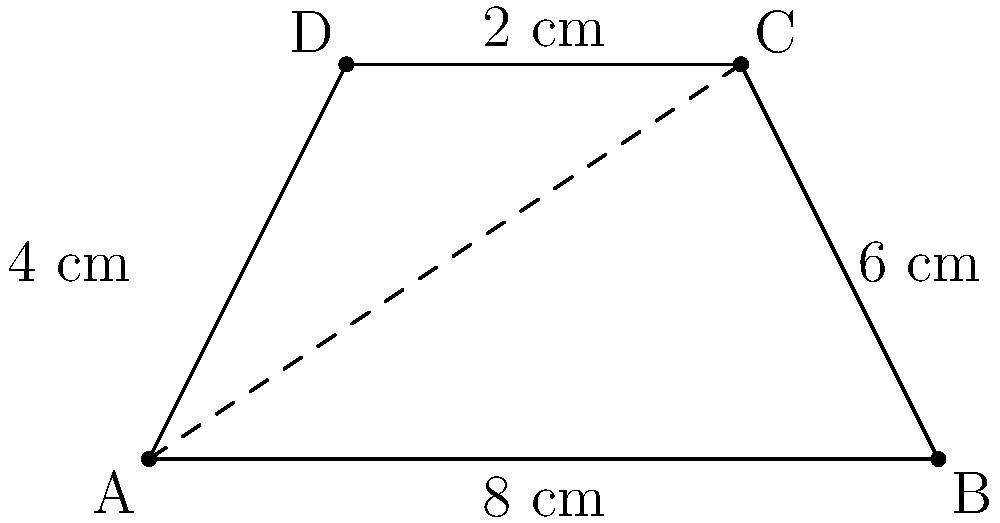In a data flow diagram represented as a trapezoid, the parallel sides measure 2 cm and 8 cm, while the height is 4 cm. Calculate the area of this trapezoid-shaped data flow diagram in square centimeters. To calculate the area of a trapezoid, we use the formula:

$$A = \frac{1}{2}(b_1 + b_2)h$$

Where:
$A$ = Area
$b_1$ = Length of one parallel side
$b_2$ = Length of the other parallel side
$h$ = Height (perpendicular distance between the parallel sides)

Given:
$b_1 = 2$ cm
$b_2 = 8$ cm
$h = 4$ cm

Let's substitute these values into the formula:

$$A = \frac{1}{2}(2 + 8) \times 4$$

$$A = \frac{1}{2}(10) \times 4$$

$$A = 5 \times 4$$

$$A = 20$$

Therefore, the area of the trapezoid-shaped data flow diagram is 20 square centimeters.
Answer: 20 cm² 